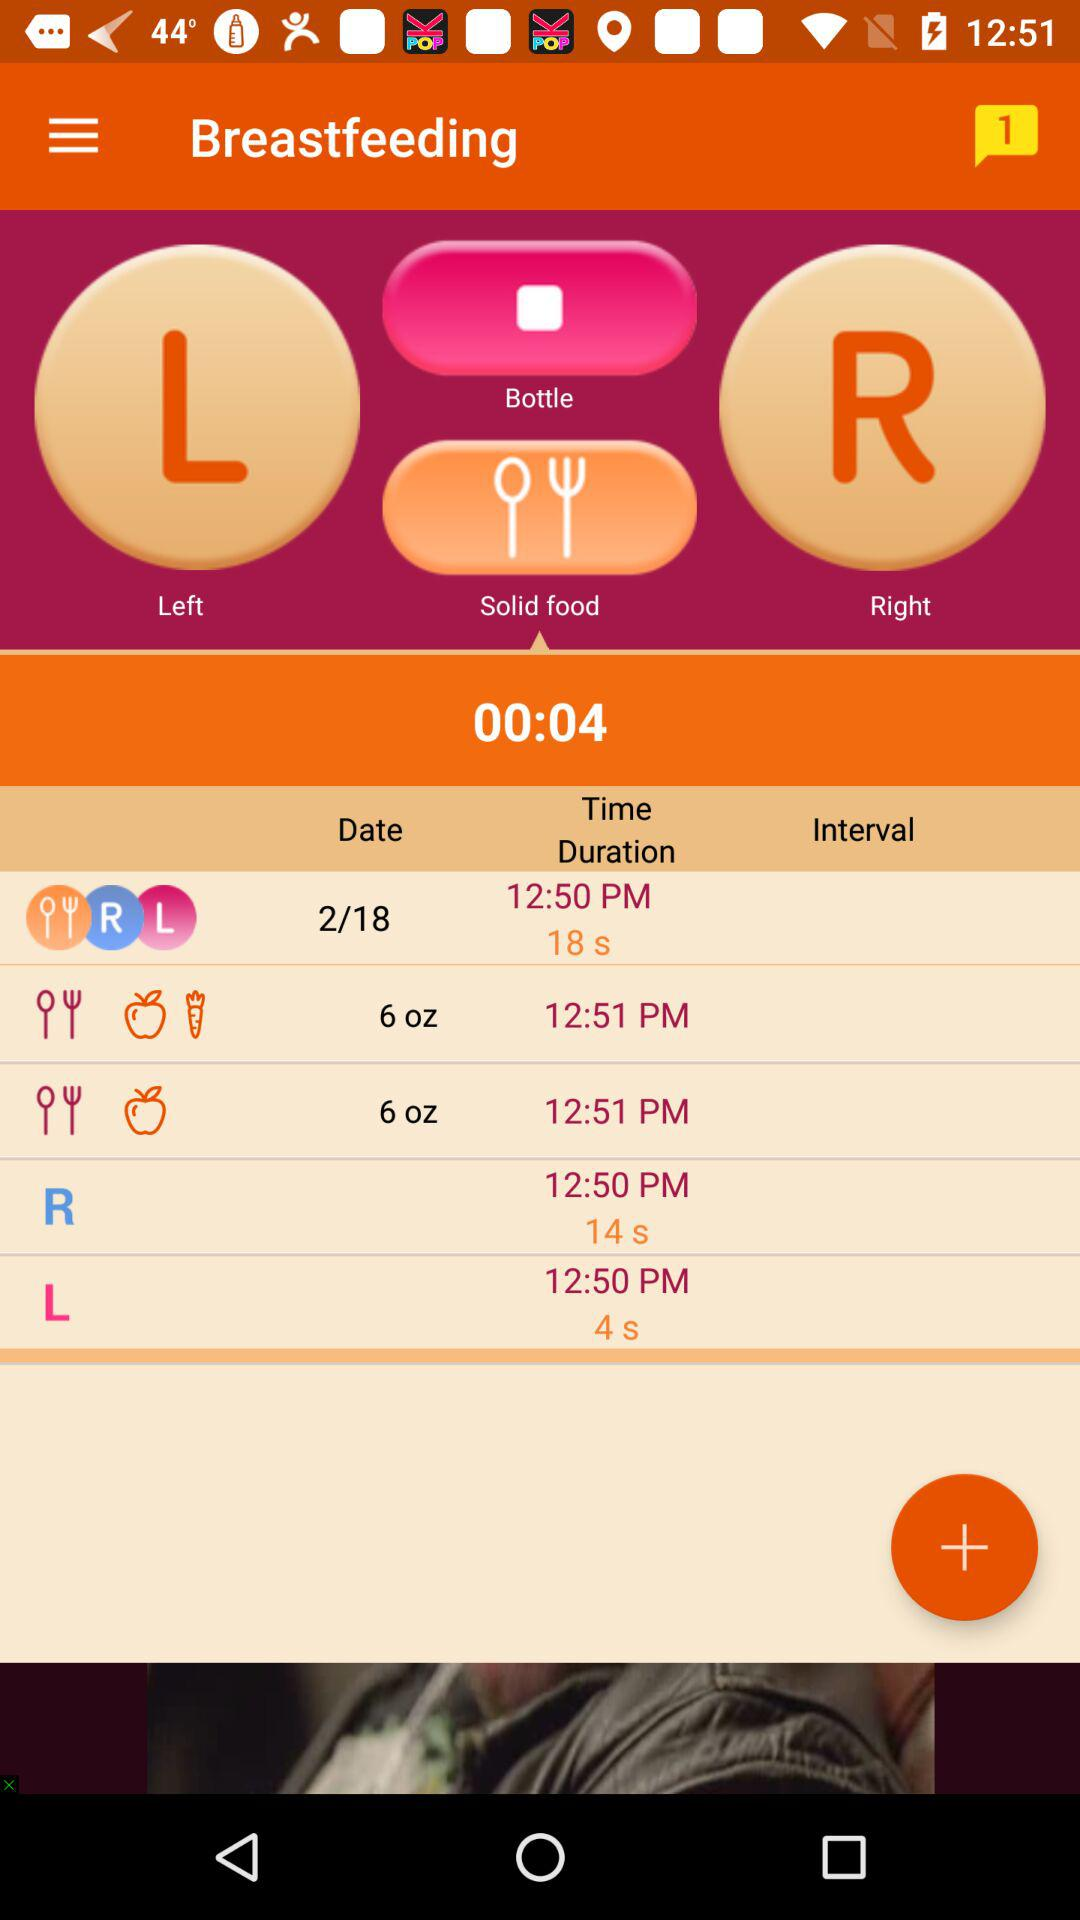What is the total duration of breastfeeding? The total duration of breastfeeding is 18 seconds. 